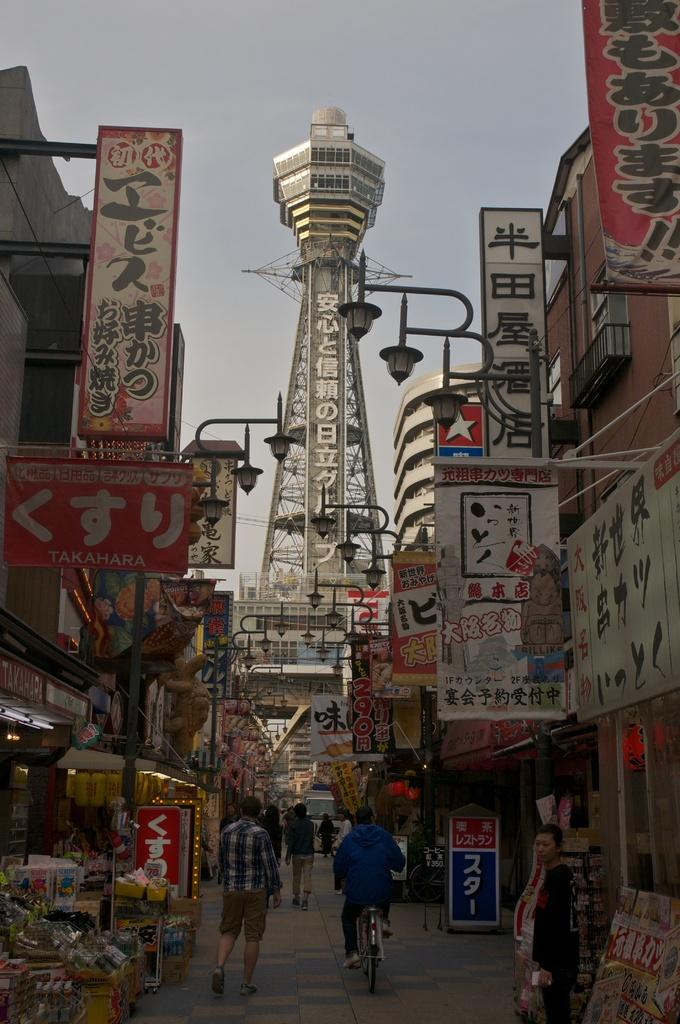What is the main structure in the image? There is a tower in the image. What else can be seen in the image besides the tower? There are buildings in the image. What activity is taking place on the road in the image? There are people walking on the road in the image. What type of order is being given by the snake in the image? There is no snake present in the image, so no order can be given by a snake. 